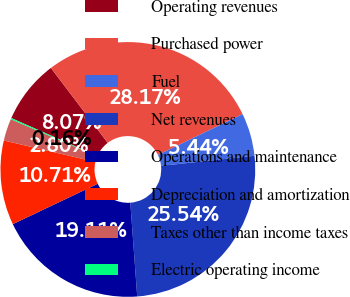Convert chart to OTSL. <chart><loc_0><loc_0><loc_500><loc_500><pie_chart><fcel>Operating revenues<fcel>Purchased power<fcel>Fuel<fcel>Net revenues<fcel>Operations and maintenance<fcel>Depreciation and amortization<fcel>Taxes other than income taxes<fcel>Electric operating income<nl><fcel>8.07%<fcel>28.17%<fcel>5.44%<fcel>25.54%<fcel>19.11%<fcel>10.71%<fcel>2.8%<fcel>0.16%<nl></chart> 